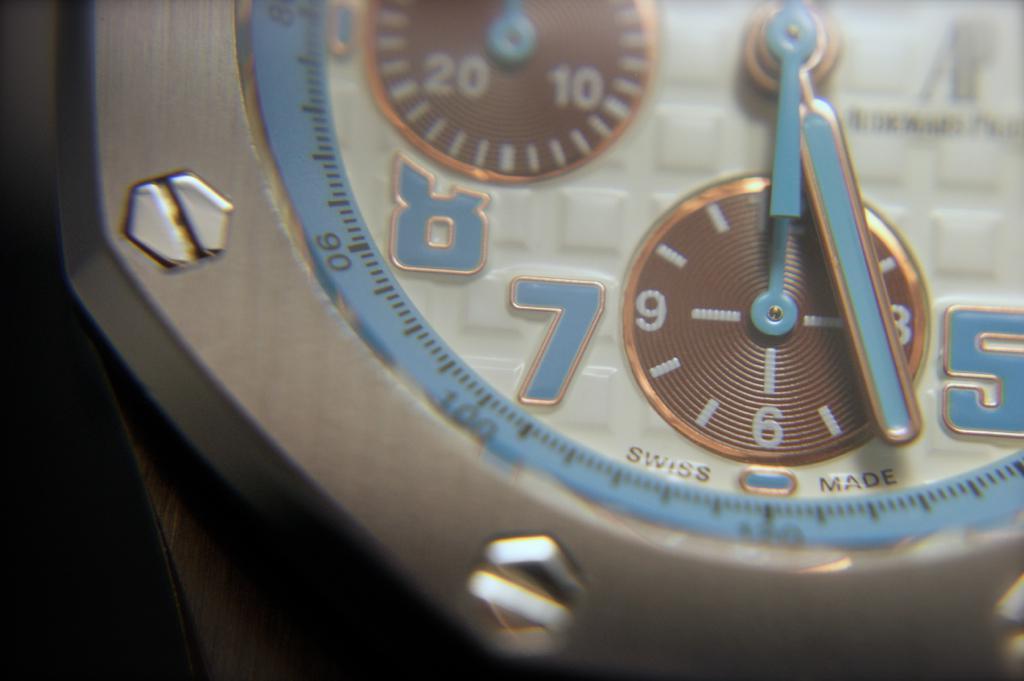Who made this watch?
Offer a terse response. Swiss. Whats the time shown ?
Provide a short and direct response. 6:27. 